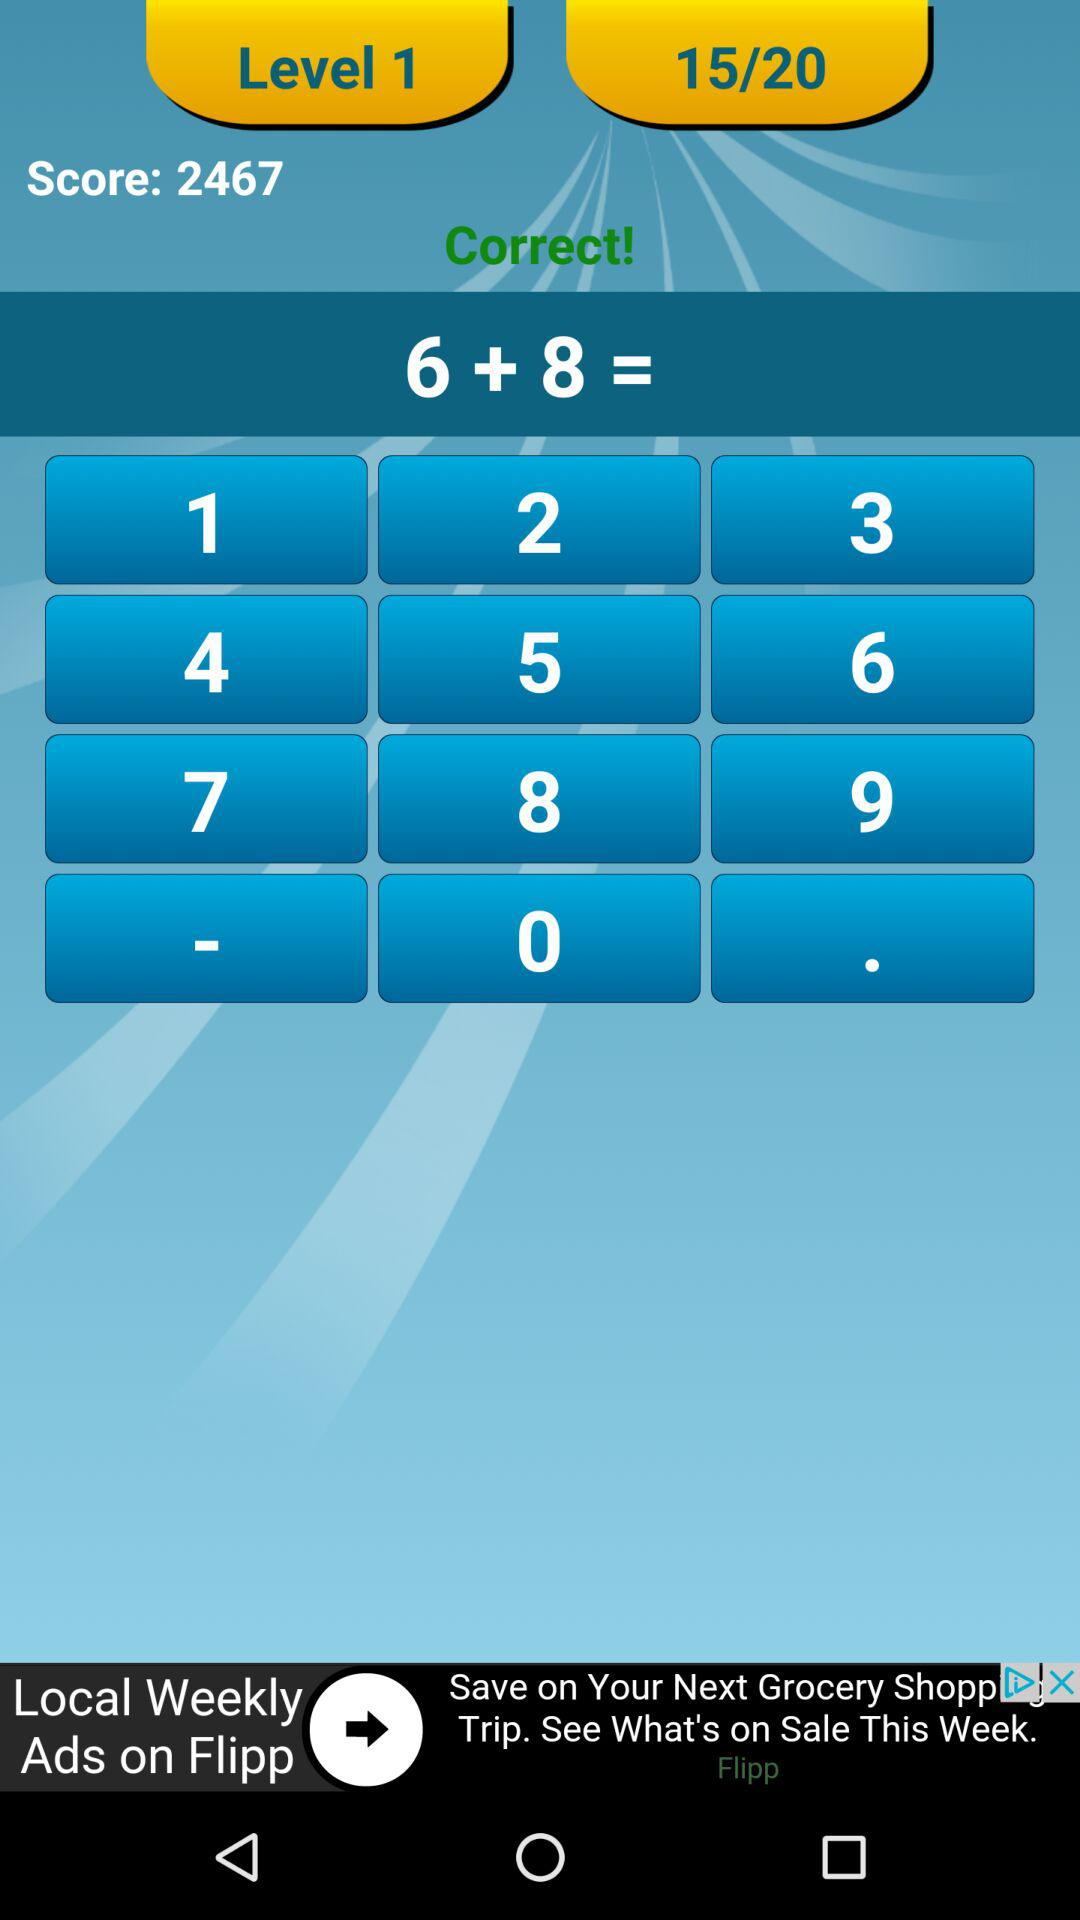What is the score? The score is 2467. 